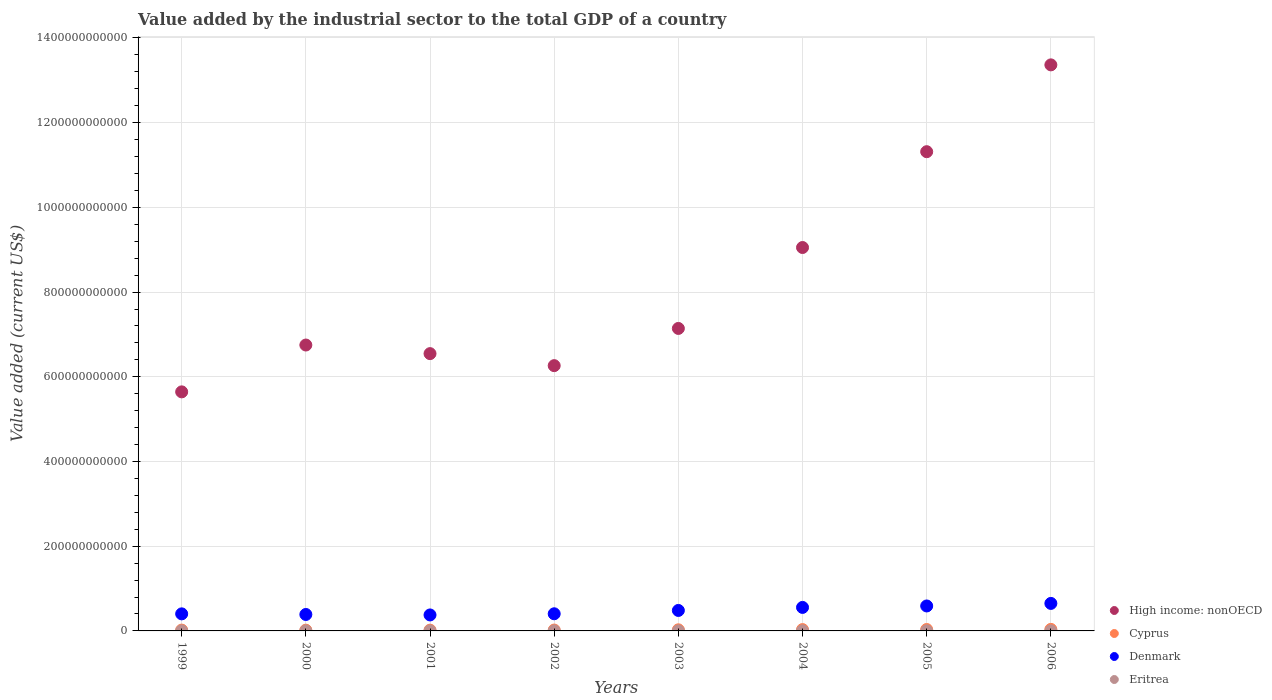How many different coloured dotlines are there?
Provide a short and direct response. 4. What is the value added by the industrial sector to the total GDP in High income: nonOECD in 2004?
Provide a short and direct response. 9.05e+11. Across all years, what is the maximum value added by the industrial sector to the total GDP in Eritrea?
Ensure brevity in your answer.  2.25e+08. Across all years, what is the minimum value added by the industrial sector to the total GDP in High income: nonOECD?
Offer a terse response. 5.64e+11. In which year was the value added by the industrial sector to the total GDP in High income: nonOECD maximum?
Give a very brief answer. 2006. What is the total value added by the industrial sector to the total GDP in Denmark in the graph?
Your answer should be compact. 3.85e+11. What is the difference between the value added by the industrial sector to the total GDP in Cyprus in 2000 and that in 2001?
Ensure brevity in your answer.  -4.46e+07. What is the difference between the value added by the industrial sector to the total GDP in Denmark in 2002 and the value added by the industrial sector to the total GDP in Eritrea in 2000?
Provide a succinct answer. 4.03e+1. What is the average value added by the industrial sector to the total GDP in Denmark per year?
Provide a short and direct response. 4.81e+1. In the year 2000, what is the difference between the value added by the industrial sector to the total GDP in High income: nonOECD and value added by the industrial sector to the total GDP in Eritrea?
Provide a succinct answer. 6.75e+11. What is the ratio of the value added by the industrial sector to the total GDP in Cyprus in 1999 to that in 2001?
Keep it short and to the point. 1.07. What is the difference between the highest and the second highest value added by the industrial sector to the total GDP in Denmark?
Provide a short and direct response. 6.02e+09. What is the difference between the highest and the lowest value added by the industrial sector to the total GDP in Cyprus?
Keep it short and to the point. 1.83e+09. Is the value added by the industrial sector to the total GDP in Cyprus strictly greater than the value added by the industrial sector to the total GDP in Denmark over the years?
Make the answer very short. No. How many dotlines are there?
Provide a succinct answer. 4. How many years are there in the graph?
Your answer should be compact. 8. What is the difference between two consecutive major ticks on the Y-axis?
Your response must be concise. 2.00e+11. Are the values on the major ticks of Y-axis written in scientific E-notation?
Make the answer very short. No. How many legend labels are there?
Provide a succinct answer. 4. What is the title of the graph?
Offer a terse response. Value added by the industrial sector to the total GDP of a country. Does "Suriname" appear as one of the legend labels in the graph?
Your response must be concise. No. What is the label or title of the X-axis?
Give a very brief answer. Years. What is the label or title of the Y-axis?
Give a very brief answer. Value added (current US$). What is the Value added (current US$) in High income: nonOECD in 1999?
Offer a very short reply. 5.64e+11. What is the Value added (current US$) of Cyprus in 1999?
Provide a short and direct response. 1.96e+09. What is the Value added (current US$) in Denmark in 1999?
Provide a succinct answer. 4.03e+1. What is the Value added (current US$) in Eritrea in 1999?
Your response must be concise. 1.44e+08. What is the Value added (current US$) of High income: nonOECD in 2000?
Make the answer very short. 6.75e+11. What is the Value added (current US$) in Cyprus in 2000?
Give a very brief answer. 1.78e+09. What is the Value added (current US$) of Denmark in 2000?
Keep it short and to the point. 3.88e+1. What is the Value added (current US$) of Eritrea in 2000?
Ensure brevity in your answer.  1.35e+08. What is the Value added (current US$) of High income: nonOECD in 2001?
Provide a short and direct response. 6.55e+11. What is the Value added (current US$) of Cyprus in 2001?
Give a very brief answer. 1.83e+09. What is the Value added (current US$) in Denmark in 2001?
Provide a succinct answer. 3.77e+1. What is the Value added (current US$) in Eritrea in 2001?
Your response must be concise. 1.39e+08. What is the Value added (current US$) in High income: nonOECD in 2002?
Provide a succinct answer. 6.26e+11. What is the Value added (current US$) of Cyprus in 2002?
Provide a succinct answer. 2.07e+09. What is the Value added (current US$) in Denmark in 2002?
Your response must be concise. 4.05e+1. What is the Value added (current US$) in Eritrea in 2002?
Your response must be concise. 1.40e+08. What is the Value added (current US$) of High income: nonOECD in 2003?
Provide a short and direct response. 7.14e+11. What is the Value added (current US$) in Cyprus in 2003?
Your answer should be compact. 2.64e+09. What is the Value added (current US$) of Denmark in 2003?
Provide a succinct answer. 4.83e+1. What is the Value added (current US$) of Eritrea in 2003?
Give a very brief answer. 1.71e+08. What is the Value added (current US$) of High income: nonOECD in 2004?
Your answer should be compact. 9.05e+11. What is the Value added (current US$) in Cyprus in 2004?
Make the answer very short. 3.17e+09. What is the Value added (current US$) of Denmark in 2004?
Make the answer very short. 5.55e+1. What is the Value added (current US$) in Eritrea in 2004?
Ensure brevity in your answer.  2.18e+08. What is the Value added (current US$) in High income: nonOECD in 2005?
Offer a terse response. 1.13e+12. What is the Value added (current US$) of Cyprus in 2005?
Provide a short and direct response. 3.34e+09. What is the Value added (current US$) in Denmark in 2005?
Keep it short and to the point. 5.89e+1. What is the Value added (current US$) of Eritrea in 2005?
Provide a short and direct response. 2.25e+08. What is the Value added (current US$) of High income: nonOECD in 2006?
Provide a short and direct response. 1.34e+12. What is the Value added (current US$) of Cyprus in 2006?
Your response must be concise. 3.62e+09. What is the Value added (current US$) of Denmark in 2006?
Offer a very short reply. 6.49e+1. What is the Value added (current US$) of Eritrea in 2006?
Offer a terse response. 2.20e+08. Across all years, what is the maximum Value added (current US$) in High income: nonOECD?
Make the answer very short. 1.34e+12. Across all years, what is the maximum Value added (current US$) in Cyprus?
Give a very brief answer. 3.62e+09. Across all years, what is the maximum Value added (current US$) of Denmark?
Give a very brief answer. 6.49e+1. Across all years, what is the maximum Value added (current US$) of Eritrea?
Make the answer very short. 2.25e+08. Across all years, what is the minimum Value added (current US$) of High income: nonOECD?
Your response must be concise. 5.64e+11. Across all years, what is the minimum Value added (current US$) in Cyprus?
Offer a terse response. 1.78e+09. Across all years, what is the minimum Value added (current US$) in Denmark?
Offer a very short reply. 3.77e+1. Across all years, what is the minimum Value added (current US$) in Eritrea?
Keep it short and to the point. 1.35e+08. What is the total Value added (current US$) in High income: nonOECD in the graph?
Ensure brevity in your answer.  6.61e+12. What is the total Value added (current US$) of Cyprus in the graph?
Keep it short and to the point. 2.04e+1. What is the total Value added (current US$) in Denmark in the graph?
Keep it short and to the point. 3.85e+11. What is the total Value added (current US$) in Eritrea in the graph?
Make the answer very short. 1.39e+09. What is the difference between the Value added (current US$) in High income: nonOECD in 1999 and that in 2000?
Ensure brevity in your answer.  -1.11e+11. What is the difference between the Value added (current US$) of Cyprus in 1999 and that in 2000?
Your response must be concise. 1.76e+08. What is the difference between the Value added (current US$) of Denmark in 1999 and that in 2000?
Make the answer very short. 1.46e+09. What is the difference between the Value added (current US$) of Eritrea in 1999 and that in 2000?
Your answer should be very brief. 8.46e+06. What is the difference between the Value added (current US$) in High income: nonOECD in 1999 and that in 2001?
Make the answer very short. -9.03e+1. What is the difference between the Value added (current US$) in Cyprus in 1999 and that in 2001?
Provide a succinct answer. 1.31e+08. What is the difference between the Value added (current US$) in Denmark in 1999 and that in 2001?
Provide a short and direct response. 2.57e+09. What is the difference between the Value added (current US$) of Eritrea in 1999 and that in 2001?
Ensure brevity in your answer.  4.37e+06. What is the difference between the Value added (current US$) in High income: nonOECD in 1999 and that in 2002?
Make the answer very short. -6.19e+1. What is the difference between the Value added (current US$) in Cyprus in 1999 and that in 2002?
Your answer should be very brief. -1.07e+08. What is the difference between the Value added (current US$) of Denmark in 1999 and that in 2002?
Keep it short and to the point. -1.83e+08. What is the difference between the Value added (current US$) in Eritrea in 1999 and that in 2002?
Ensure brevity in your answer.  3.97e+06. What is the difference between the Value added (current US$) of High income: nonOECD in 1999 and that in 2003?
Make the answer very short. -1.50e+11. What is the difference between the Value added (current US$) in Cyprus in 1999 and that in 2003?
Offer a very short reply. -6.85e+08. What is the difference between the Value added (current US$) of Denmark in 1999 and that in 2003?
Make the answer very short. -8.05e+09. What is the difference between the Value added (current US$) of Eritrea in 1999 and that in 2003?
Your answer should be compact. -2.76e+07. What is the difference between the Value added (current US$) of High income: nonOECD in 1999 and that in 2004?
Your answer should be very brief. -3.41e+11. What is the difference between the Value added (current US$) of Cyprus in 1999 and that in 2004?
Ensure brevity in your answer.  -1.21e+09. What is the difference between the Value added (current US$) in Denmark in 1999 and that in 2004?
Offer a terse response. -1.52e+1. What is the difference between the Value added (current US$) in Eritrea in 1999 and that in 2004?
Make the answer very short. -7.37e+07. What is the difference between the Value added (current US$) of High income: nonOECD in 1999 and that in 2005?
Your answer should be very brief. -5.67e+11. What is the difference between the Value added (current US$) of Cyprus in 1999 and that in 2005?
Provide a short and direct response. -1.38e+09. What is the difference between the Value added (current US$) of Denmark in 1999 and that in 2005?
Offer a very short reply. -1.86e+1. What is the difference between the Value added (current US$) in Eritrea in 1999 and that in 2005?
Provide a succinct answer. -8.10e+07. What is the difference between the Value added (current US$) in High income: nonOECD in 1999 and that in 2006?
Make the answer very short. -7.72e+11. What is the difference between the Value added (current US$) of Cyprus in 1999 and that in 2006?
Offer a terse response. -1.66e+09. What is the difference between the Value added (current US$) of Denmark in 1999 and that in 2006?
Keep it short and to the point. -2.46e+1. What is the difference between the Value added (current US$) in Eritrea in 1999 and that in 2006?
Provide a short and direct response. -7.61e+07. What is the difference between the Value added (current US$) of High income: nonOECD in 2000 and that in 2001?
Offer a very short reply. 2.03e+1. What is the difference between the Value added (current US$) of Cyprus in 2000 and that in 2001?
Ensure brevity in your answer.  -4.46e+07. What is the difference between the Value added (current US$) in Denmark in 2000 and that in 2001?
Give a very brief answer. 1.11e+09. What is the difference between the Value added (current US$) in Eritrea in 2000 and that in 2001?
Make the answer very short. -4.09e+06. What is the difference between the Value added (current US$) in High income: nonOECD in 2000 and that in 2002?
Give a very brief answer. 4.87e+1. What is the difference between the Value added (current US$) of Cyprus in 2000 and that in 2002?
Your answer should be very brief. -2.83e+08. What is the difference between the Value added (current US$) of Denmark in 2000 and that in 2002?
Provide a succinct answer. -1.64e+09. What is the difference between the Value added (current US$) of Eritrea in 2000 and that in 2002?
Offer a very short reply. -4.49e+06. What is the difference between the Value added (current US$) in High income: nonOECD in 2000 and that in 2003?
Your answer should be very brief. -3.92e+1. What is the difference between the Value added (current US$) of Cyprus in 2000 and that in 2003?
Provide a succinct answer. -8.61e+08. What is the difference between the Value added (current US$) in Denmark in 2000 and that in 2003?
Offer a very short reply. -9.51e+09. What is the difference between the Value added (current US$) of Eritrea in 2000 and that in 2003?
Keep it short and to the point. -3.61e+07. What is the difference between the Value added (current US$) in High income: nonOECD in 2000 and that in 2004?
Your answer should be compact. -2.30e+11. What is the difference between the Value added (current US$) in Cyprus in 2000 and that in 2004?
Your answer should be very brief. -1.38e+09. What is the difference between the Value added (current US$) in Denmark in 2000 and that in 2004?
Offer a very short reply. -1.67e+1. What is the difference between the Value added (current US$) of Eritrea in 2000 and that in 2004?
Make the answer very short. -8.22e+07. What is the difference between the Value added (current US$) of High income: nonOECD in 2000 and that in 2005?
Provide a short and direct response. -4.56e+11. What is the difference between the Value added (current US$) of Cyprus in 2000 and that in 2005?
Keep it short and to the point. -1.55e+09. What is the difference between the Value added (current US$) of Denmark in 2000 and that in 2005?
Your answer should be very brief. -2.01e+1. What is the difference between the Value added (current US$) in Eritrea in 2000 and that in 2005?
Your response must be concise. -8.94e+07. What is the difference between the Value added (current US$) in High income: nonOECD in 2000 and that in 2006?
Offer a terse response. -6.61e+11. What is the difference between the Value added (current US$) of Cyprus in 2000 and that in 2006?
Your answer should be compact. -1.83e+09. What is the difference between the Value added (current US$) of Denmark in 2000 and that in 2006?
Your response must be concise. -2.61e+1. What is the difference between the Value added (current US$) in Eritrea in 2000 and that in 2006?
Your response must be concise. -8.45e+07. What is the difference between the Value added (current US$) in High income: nonOECD in 2001 and that in 2002?
Offer a terse response. 2.84e+1. What is the difference between the Value added (current US$) of Cyprus in 2001 and that in 2002?
Keep it short and to the point. -2.38e+08. What is the difference between the Value added (current US$) in Denmark in 2001 and that in 2002?
Offer a terse response. -2.75e+09. What is the difference between the Value added (current US$) of Eritrea in 2001 and that in 2002?
Keep it short and to the point. -3.99e+05. What is the difference between the Value added (current US$) of High income: nonOECD in 2001 and that in 2003?
Ensure brevity in your answer.  -5.95e+1. What is the difference between the Value added (current US$) in Cyprus in 2001 and that in 2003?
Offer a very short reply. -8.16e+08. What is the difference between the Value added (current US$) in Denmark in 2001 and that in 2003?
Make the answer very short. -1.06e+1. What is the difference between the Value added (current US$) in Eritrea in 2001 and that in 2003?
Offer a terse response. -3.20e+07. What is the difference between the Value added (current US$) of High income: nonOECD in 2001 and that in 2004?
Give a very brief answer. -2.51e+11. What is the difference between the Value added (current US$) of Cyprus in 2001 and that in 2004?
Offer a terse response. -1.34e+09. What is the difference between the Value added (current US$) of Denmark in 2001 and that in 2004?
Your answer should be very brief. -1.78e+1. What is the difference between the Value added (current US$) in Eritrea in 2001 and that in 2004?
Give a very brief answer. -7.81e+07. What is the difference between the Value added (current US$) in High income: nonOECD in 2001 and that in 2005?
Offer a very short reply. -4.77e+11. What is the difference between the Value added (current US$) in Cyprus in 2001 and that in 2005?
Provide a short and direct response. -1.51e+09. What is the difference between the Value added (current US$) of Denmark in 2001 and that in 2005?
Provide a short and direct response. -2.12e+1. What is the difference between the Value added (current US$) of Eritrea in 2001 and that in 2005?
Ensure brevity in your answer.  -8.53e+07. What is the difference between the Value added (current US$) in High income: nonOECD in 2001 and that in 2006?
Provide a short and direct response. -6.82e+11. What is the difference between the Value added (current US$) in Cyprus in 2001 and that in 2006?
Offer a very short reply. -1.79e+09. What is the difference between the Value added (current US$) in Denmark in 2001 and that in 2006?
Offer a very short reply. -2.72e+1. What is the difference between the Value added (current US$) in Eritrea in 2001 and that in 2006?
Give a very brief answer. -8.04e+07. What is the difference between the Value added (current US$) in High income: nonOECD in 2002 and that in 2003?
Ensure brevity in your answer.  -8.78e+1. What is the difference between the Value added (current US$) of Cyprus in 2002 and that in 2003?
Offer a terse response. -5.78e+08. What is the difference between the Value added (current US$) in Denmark in 2002 and that in 2003?
Keep it short and to the point. -7.87e+09. What is the difference between the Value added (current US$) in Eritrea in 2002 and that in 2003?
Keep it short and to the point. -3.16e+07. What is the difference between the Value added (current US$) in High income: nonOECD in 2002 and that in 2004?
Provide a short and direct response. -2.79e+11. What is the difference between the Value added (current US$) in Cyprus in 2002 and that in 2004?
Provide a short and direct response. -1.10e+09. What is the difference between the Value added (current US$) in Denmark in 2002 and that in 2004?
Keep it short and to the point. -1.50e+1. What is the difference between the Value added (current US$) of Eritrea in 2002 and that in 2004?
Your answer should be compact. -7.77e+07. What is the difference between the Value added (current US$) in High income: nonOECD in 2002 and that in 2005?
Keep it short and to the point. -5.05e+11. What is the difference between the Value added (current US$) in Cyprus in 2002 and that in 2005?
Keep it short and to the point. -1.27e+09. What is the difference between the Value added (current US$) of Denmark in 2002 and that in 2005?
Your answer should be very brief. -1.84e+1. What is the difference between the Value added (current US$) in Eritrea in 2002 and that in 2005?
Keep it short and to the point. -8.49e+07. What is the difference between the Value added (current US$) of High income: nonOECD in 2002 and that in 2006?
Your response must be concise. -7.10e+11. What is the difference between the Value added (current US$) of Cyprus in 2002 and that in 2006?
Offer a terse response. -1.55e+09. What is the difference between the Value added (current US$) of Denmark in 2002 and that in 2006?
Provide a succinct answer. -2.45e+1. What is the difference between the Value added (current US$) of Eritrea in 2002 and that in 2006?
Offer a terse response. -8.00e+07. What is the difference between the Value added (current US$) of High income: nonOECD in 2003 and that in 2004?
Provide a short and direct response. -1.91e+11. What is the difference between the Value added (current US$) of Cyprus in 2003 and that in 2004?
Your answer should be very brief. -5.21e+08. What is the difference between the Value added (current US$) of Denmark in 2003 and that in 2004?
Keep it short and to the point. -7.16e+09. What is the difference between the Value added (current US$) in Eritrea in 2003 and that in 2004?
Ensure brevity in your answer.  -4.61e+07. What is the difference between the Value added (current US$) of High income: nonOECD in 2003 and that in 2005?
Offer a terse response. -4.17e+11. What is the difference between the Value added (current US$) of Cyprus in 2003 and that in 2005?
Your answer should be compact. -6.91e+08. What is the difference between the Value added (current US$) of Denmark in 2003 and that in 2005?
Your response must be concise. -1.06e+1. What is the difference between the Value added (current US$) in Eritrea in 2003 and that in 2005?
Ensure brevity in your answer.  -5.34e+07. What is the difference between the Value added (current US$) of High income: nonOECD in 2003 and that in 2006?
Offer a very short reply. -6.22e+11. What is the difference between the Value added (current US$) of Cyprus in 2003 and that in 2006?
Make the answer very short. -9.73e+08. What is the difference between the Value added (current US$) of Denmark in 2003 and that in 2006?
Make the answer very short. -1.66e+1. What is the difference between the Value added (current US$) in Eritrea in 2003 and that in 2006?
Give a very brief answer. -4.85e+07. What is the difference between the Value added (current US$) in High income: nonOECD in 2004 and that in 2005?
Ensure brevity in your answer.  -2.26e+11. What is the difference between the Value added (current US$) in Cyprus in 2004 and that in 2005?
Provide a succinct answer. -1.69e+08. What is the difference between the Value added (current US$) of Denmark in 2004 and that in 2005?
Ensure brevity in your answer.  -3.41e+09. What is the difference between the Value added (current US$) of Eritrea in 2004 and that in 2005?
Your answer should be very brief. -7.25e+06. What is the difference between the Value added (current US$) in High income: nonOECD in 2004 and that in 2006?
Keep it short and to the point. -4.31e+11. What is the difference between the Value added (current US$) of Cyprus in 2004 and that in 2006?
Provide a succinct answer. -4.51e+08. What is the difference between the Value added (current US$) of Denmark in 2004 and that in 2006?
Offer a terse response. -9.43e+09. What is the difference between the Value added (current US$) of Eritrea in 2004 and that in 2006?
Your answer should be very brief. -2.35e+06. What is the difference between the Value added (current US$) of High income: nonOECD in 2005 and that in 2006?
Your response must be concise. -2.05e+11. What is the difference between the Value added (current US$) of Cyprus in 2005 and that in 2006?
Your response must be concise. -2.82e+08. What is the difference between the Value added (current US$) in Denmark in 2005 and that in 2006?
Give a very brief answer. -6.02e+09. What is the difference between the Value added (current US$) in Eritrea in 2005 and that in 2006?
Give a very brief answer. 4.90e+06. What is the difference between the Value added (current US$) in High income: nonOECD in 1999 and the Value added (current US$) in Cyprus in 2000?
Provide a short and direct response. 5.63e+11. What is the difference between the Value added (current US$) of High income: nonOECD in 1999 and the Value added (current US$) of Denmark in 2000?
Offer a terse response. 5.26e+11. What is the difference between the Value added (current US$) of High income: nonOECD in 1999 and the Value added (current US$) of Eritrea in 2000?
Provide a succinct answer. 5.64e+11. What is the difference between the Value added (current US$) of Cyprus in 1999 and the Value added (current US$) of Denmark in 2000?
Provide a succinct answer. -3.69e+1. What is the difference between the Value added (current US$) of Cyprus in 1999 and the Value added (current US$) of Eritrea in 2000?
Your answer should be very brief. 1.82e+09. What is the difference between the Value added (current US$) of Denmark in 1999 and the Value added (current US$) of Eritrea in 2000?
Your answer should be very brief. 4.02e+1. What is the difference between the Value added (current US$) in High income: nonOECD in 1999 and the Value added (current US$) in Cyprus in 2001?
Provide a succinct answer. 5.63e+11. What is the difference between the Value added (current US$) of High income: nonOECD in 1999 and the Value added (current US$) of Denmark in 2001?
Provide a short and direct response. 5.27e+11. What is the difference between the Value added (current US$) in High income: nonOECD in 1999 and the Value added (current US$) in Eritrea in 2001?
Offer a very short reply. 5.64e+11. What is the difference between the Value added (current US$) in Cyprus in 1999 and the Value added (current US$) in Denmark in 2001?
Your answer should be very brief. -3.58e+1. What is the difference between the Value added (current US$) in Cyprus in 1999 and the Value added (current US$) in Eritrea in 2001?
Your response must be concise. 1.82e+09. What is the difference between the Value added (current US$) of Denmark in 1999 and the Value added (current US$) of Eritrea in 2001?
Provide a succinct answer. 4.01e+1. What is the difference between the Value added (current US$) in High income: nonOECD in 1999 and the Value added (current US$) in Cyprus in 2002?
Keep it short and to the point. 5.62e+11. What is the difference between the Value added (current US$) of High income: nonOECD in 1999 and the Value added (current US$) of Denmark in 2002?
Offer a very short reply. 5.24e+11. What is the difference between the Value added (current US$) in High income: nonOECD in 1999 and the Value added (current US$) in Eritrea in 2002?
Offer a terse response. 5.64e+11. What is the difference between the Value added (current US$) in Cyprus in 1999 and the Value added (current US$) in Denmark in 2002?
Offer a very short reply. -3.85e+1. What is the difference between the Value added (current US$) in Cyprus in 1999 and the Value added (current US$) in Eritrea in 2002?
Make the answer very short. 1.82e+09. What is the difference between the Value added (current US$) of Denmark in 1999 and the Value added (current US$) of Eritrea in 2002?
Offer a very short reply. 4.01e+1. What is the difference between the Value added (current US$) of High income: nonOECD in 1999 and the Value added (current US$) of Cyprus in 2003?
Make the answer very short. 5.62e+11. What is the difference between the Value added (current US$) in High income: nonOECD in 1999 and the Value added (current US$) in Denmark in 2003?
Ensure brevity in your answer.  5.16e+11. What is the difference between the Value added (current US$) in High income: nonOECD in 1999 and the Value added (current US$) in Eritrea in 2003?
Provide a short and direct response. 5.64e+11. What is the difference between the Value added (current US$) in Cyprus in 1999 and the Value added (current US$) in Denmark in 2003?
Give a very brief answer. -4.64e+1. What is the difference between the Value added (current US$) in Cyprus in 1999 and the Value added (current US$) in Eritrea in 2003?
Your answer should be compact. 1.79e+09. What is the difference between the Value added (current US$) in Denmark in 1999 and the Value added (current US$) in Eritrea in 2003?
Your response must be concise. 4.01e+1. What is the difference between the Value added (current US$) of High income: nonOECD in 1999 and the Value added (current US$) of Cyprus in 2004?
Your response must be concise. 5.61e+11. What is the difference between the Value added (current US$) in High income: nonOECD in 1999 and the Value added (current US$) in Denmark in 2004?
Your response must be concise. 5.09e+11. What is the difference between the Value added (current US$) of High income: nonOECD in 1999 and the Value added (current US$) of Eritrea in 2004?
Keep it short and to the point. 5.64e+11. What is the difference between the Value added (current US$) of Cyprus in 1999 and the Value added (current US$) of Denmark in 2004?
Offer a terse response. -5.35e+1. What is the difference between the Value added (current US$) of Cyprus in 1999 and the Value added (current US$) of Eritrea in 2004?
Make the answer very short. 1.74e+09. What is the difference between the Value added (current US$) of Denmark in 1999 and the Value added (current US$) of Eritrea in 2004?
Provide a short and direct response. 4.01e+1. What is the difference between the Value added (current US$) in High income: nonOECD in 1999 and the Value added (current US$) in Cyprus in 2005?
Ensure brevity in your answer.  5.61e+11. What is the difference between the Value added (current US$) of High income: nonOECD in 1999 and the Value added (current US$) of Denmark in 2005?
Provide a short and direct response. 5.05e+11. What is the difference between the Value added (current US$) in High income: nonOECD in 1999 and the Value added (current US$) in Eritrea in 2005?
Keep it short and to the point. 5.64e+11. What is the difference between the Value added (current US$) of Cyprus in 1999 and the Value added (current US$) of Denmark in 2005?
Your answer should be compact. -5.70e+1. What is the difference between the Value added (current US$) of Cyprus in 1999 and the Value added (current US$) of Eritrea in 2005?
Provide a short and direct response. 1.74e+09. What is the difference between the Value added (current US$) of Denmark in 1999 and the Value added (current US$) of Eritrea in 2005?
Offer a terse response. 4.01e+1. What is the difference between the Value added (current US$) in High income: nonOECD in 1999 and the Value added (current US$) in Cyprus in 2006?
Provide a succinct answer. 5.61e+11. What is the difference between the Value added (current US$) of High income: nonOECD in 1999 and the Value added (current US$) of Denmark in 2006?
Your response must be concise. 4.99e+11. What is the difference between the Value added (current US$) of High income: nonOECD in 1999 and the Value added (current US$) of Eritrea in 2006?
Make the answer very short. 5.64e+11. What is the difference between the Value added (current US$) of Cyprus in 1999 and the Value added (current US$) of Denmark in 2006?
Your response must be concise. -6.30e+1. What is the difference between the Value added (current US$) in Cyprus in 1999 and the Value added (current US$) in Eritrea in 2006?
Offer a very short reply. 1.74e+09. What is the difference between the Value added (current US$) of Denmark in 1999 and the Value added (current US$) of Eritrea in 2006?
Keep it short and to the point. 4.01e+1. What is the difference between the Value added (current US$) of High income: nonOECD in 2000 and the Value added (current US$) of Cyprus in 2001?
Keep it short and to the point. 6.73e+11. What is the difference between the Value added (current US$) of High income: nonOECD in 2000 and the Value added (current US$) of Denmark in 2001?
Your answer should be very brief. 6.37e+11. What is the difference between the Value added (current US$) of High income: nonOECD in 2000 and the Value added (current US$) of Eritrea in 2001?
Keep it short and to the point. 6.75e+11. What is the difference between the Value added (current US$) in Cyprus in 2000 and the Value added (current US$) in Denmark in 2001?
Offer a very short reply. -3.59e+1. What is the difference between the Value added (current US$) in Cyprus in 2000 and the Value added (current US$) in Eritrea in 2001?
Offer a very short reply. 1.64e+09. What is the difference between the Value added (current US$) of Denmark in 2000 and the Value added (current US$) of Eritrea in 2001?
Offer a terse response. 3.87e+1. What is the difference between the Value added (current US$) in High income: nonOECD in 2000 and the Value added (current US$) in Cyprus in 2002?
Your answer should be compact. 6.73e+11. What is the difference between the Value added (current US$) of High income: nonOECD in 2000 and the Value added (current US$) of Denmark in 2002?
Your answer should be compact. 6.35e+11. What is the difference between the Value added (current US$) in High income: nonOECD in 2000 and the Value added (current US$) in Eritrea in 2002?
Provide a succinct answer. 6.75e+11. What is the difference between the Value added (current US$) in Cyprus in 2000 and the Value added (current US$) in Denmark in 2002?
Your answer should be very brief. -3.87e+1. What is the difference between the Value added (current US$) in Cyprus in 2000 and the Value added (current US$) in Eritrea in 2002?
Give a very brief answer. 1.64e+09. What is the difference between the Value added (current US$) in Denmark in 2000 and the Value added (current US$) in Eritrea in 2002?
Make the answer very short. 3.87e+1. What is the difference between the Value added (current US$) in High income: nonOECD in 2000 and the Value added (current US$) in Cyprus in 2003?
Ensure brevity in your answer.  6.72e+11. What is the difference between the Value added (current US$) in High income: nonOECD in 2000 and the Value added (current US$) in Denmark in 2003?
Offer a terse response. 6.27e+11. What is the difference between the Value added (current US$) of High income: nonOECD in 2000 and the Value added (current US$) of Eritrea in 2003?
Your answer should be compact. 6.75e+11. What is the difference between the Value added (current US$) in Cyprus in 2000 and the Value added (current US$) in Denmark in 2003?
Keep it short and to the point. -4.66e+1. What is the difference between the Value added (current US$) in Cyprus in 2000 and the Value added (current US$) in Eritrea in 2003?
Offer a very short reply. 1.61e+09. What is the difference between the Value added (current US$) in Denmark in 2000 and the Value added (current US$) in Eritrea in 2003?
Provide a succinct answer. 3.87e+1. What is the difference between the Value added (current US$) in High income: nonOECD in 2000 and the Value added (current US$) in Cyprus in 2004?
Provide a succinct answer. 6.72e+11. What is the difference between the Value added (current US$) of High income: nonOECD in 2000 and the Value added (current US$) of Denmark in 2004?
Offer a very short reply. 6.19e+11. What is the difference between the Value added (current US$) in High income: nonOECD in 2000 and the Value added (current US$) in Eritrea in 2004?
Give a very brief answer. 6.75e+11. What is the difference between the Value added (current US$) in Cyprus in 2000 and the Value added (current US$) in Denmark in 2004?
Offer a very short reply. -5.37e+1. What is the difference between the Value added (current US$) in Cyprus in 2000 and the Value added (current US$) in Eritrea in 2004?
Offer a very short reply. 1.57e+09. What is the difference between the Value added (current US$) of Denmark in 2000 and the Value added (current US$) of Eritrea in 2004?
Provide a succinct answer. 3.86e+1. What is the difference between the Value added (current US$) of High income: nonOECD in 2000 and the Value added (current US$) of Cyprus in 2005?
Ensure brevity in your answer.  6.72e+11. What is the difference between the Value added (current US$) in High income: nonOECD in 2000 and the Value added (current US$) in Denmark in 2005?
Your response must be concise. 6.16e+11. What is the difference between the Value added (current US$) of High income: nonOECD in 2000 and the Value added (current US$) of Eritrea in 2005?
Your answer should be very brief. 6.75e+11. What is the difference between the Value added (current US$) of Cyprus in 2000 and the Value added (current US$) of Denmark in 2005?
Give a very brief answer. -5.71e+1. What is the difference between the Value added (current US$) of Cyprus in 2000 and the Value added (current US$) of Eritrea in 2005?
Your answer should be very brief. 1.56e+09. What is the difference between the Value added (current US$) of Denmark in 2000 and the Value added (current US$) of Eritrea in 2005?
Ensure brevity in your answer.  3.86e+1. What is the difference between the Value added (current US$) in High income: nonOECD in 2000 and the Value added (current US$) in Cyprus in 2006?
Your response must be concise. 6.71e+11. What is the difference between the Value added (current US$) in High income: nonOECD in 2000 and the Value added (current US$) in Denmark in 2006?
Keep it short and to the point. 6.10e+11. What is the difference between the Value added (current US$) of High income: nonOECD in 2000 and the Value added (current US$) of Eritrea in 2006?
Keep it short and to the point. 6.75e+11. What is the difference between the Value added (current US$) in Cyprus in 2000 and the Value added (current US$) in Denmark in 2006?
Offer a very short reply. -6.31e+1. What is the difference between the Value added (current US$) of Cyprus in 2000 and the Value added (current US$) of Eritrea in 2006?
Keep it short and to the point. 1.56e+09. What is the difference between the Value added (current US$) of Denmark in 2000 and the Value added (current US$) of Eritrea in 2006?
Your response must be concise. 3.86e+1. What is the difference between the Value added (current US$) in High income: nonOECD in 2001 and the Value added (current US$) in Cyprus in 2002?
Provide a succinct answer. 6.53e+11. What is the difference between the Value added (current US$) in High income: nonOECD in 2001 and the Value added (current US$) in Denmark in 2002?
Provide a short and direct response. 6.14e+11. What is the difference between the Value added (current US$) of High income: nonOECD in 2001 and the Value added (current US$) of Eritrea in 2002?
Provide a short and direct response. 6.55e+11. What is the difference between the Value added (current US$) in Cyprus in 2001 and the Value added (current US$) in Denmark in 2002?
Give a very brief answer. -3.86e+1. What is the difference between the Value added (current US$) in Cyprus in 2001 and the Value added (current US$) in Eritrea in 2002?
Your response must be concise. 1.69e+09. What is the difference between the Value added (current US$) in Denmark in 2001 and the Value added (current US$) in Eritrea in 2002?
Keep it short and to the point. 3.76e+1. What is the difference between the Value added (current US$) of High income: nonOECD in 2001 and the Value added (current US$) of Cyprus in 2003?
Keep it short and to the point. 6.52e+11. What is the difference between the Value added (current US$) in High income: nonOECD in 2001 and the Value added (current US$) in Denmark in 2003?
Offer a terse response. 6.06e+11. What is the difference between the Value added (current US$) in High income: nonOECD in 2001 and the Value added (current US$) in Eritrea in 2003?
Provide a succinct answer. 6.54e+11. What is the difference between the Value added (current US$) of Cyprus in 2001 and the Value added (current US$) of Denmark in 2003?
Offer a terse response. -4.65e+1. What is the difference between the Value added (current US$) in Cyprus in 2001 and the Value added (current US$) in Eritrea in 2003?
Give a very brief answer. 1.66e+09. What is the difference between the Value added (current US$) of Denmark in 2001 and the Value added (current US$) of Eritrea in 2003?
Provide a short and direct response. 3.76e+1. What is the difference between the Value added (current US$) in High income: nonOECD in 2001 and the Value added (current US$) in Cyprus in 2004?
Your answer should be compact. 6.52e+11. What is the difference between the Value added (current US$) of High income: nonOECD in 2001 and the Value added (current US$) of Denmark in 2004?
Offer a terse response. 5.99e+11. What is the difference between the Value added (current US$) in High income: nonOECD in 2001 and the Value added (current US$) in Eritrea in 2004?
Offer a terse response. 6.54e+11. What is the difference between the Value added (current US$) of Cyprus in 2001 and the Value added (current US$) of Denmark in 2004?
Make the answer very short. -5.37e+1. What is the difference between the Value added (current US$) in Cyprus in 2001 and the Value added (current US$) in Eritrea in 2004?
Keep it short and to the point. 1.61e+09. What is the difference between the Value added (current US$) of Denmark in 2001 and the Value added (current US$) of Eritrea in 2004?
Keep it short and to the point. 3.75e+1. What is the difference between the Value added (current US$) of High income: nonOECD in 2001 and the Value added (current US$) of Cyprus in 2005?
Offer a very short reply. 6.51e+11. What is the difference between the Value added (current US$) of High income: nonOECD in 2001 and the Value added (current US$) of Denmark in 2005?
Provide a succinct answer. 5.96e+11. What is the difference between the Value added (current US$) of High income: nonOECD in 2001 and the Value added (current US$) of Eritrea in 2005?
Make the answer very short. 6.54e+11. What is the difference between the Value added (current US$) of Cyprus in 2001 and the Value added (current US$) of Denmark in 2005?
Ensure brevity in your answer.  -5.71e+1. What is the difference between the Value added (current US$) in Cyprus in 2001 and the Value added (current US$) in Eritrea in 2005?
Offer a very short reply. 1.60e+09. What is the difference between the Value added (current US$) of Denmark in 2001 and the Value added (current US$) of Eritrea in 2005?
Your answer should be very brief. 3.75e+1. What is the difference between the Value added (current US$) of High income: nonOECD in 2001 and the Value added (current US$) of Cyprus in 2006?
Ensure brevity in your answer.  6.51e+11. What is the difference between the Value added (current US$) of High income: nonOECD in 2001 and the Value added (current US$) of Denmark in 2006?
Keep it short and to the point. 5.90e+11. What is the difference between the Value added (current US$) of High income: nonOECD in 2001 and the Value added (current US$) of Eritrea in 2006?
Make the answer very short. 6.54e+11. What is the difference between the Value added (current US$) in Cyprus in 2001 and the Value added (current US$) in Denmark in 2006?
Provide a short and direct response. -6.31e+1. What is the difference between the Value added (current US$) of Cyprus in 2001 and the Value added (current US$) of Eritrea in 2006?
Offer a terse response. 1.61e+09. What is the difference between the Value added (current US$) of Denmark in 2001 and the Value added (current US$) of Eritrea in 2006?
Your answer should be very brief. 3.75e+1. What is the difference between the Value added (current US$) in High income: nonOECD in 2002 and the Value added (current US$) in Cyprus in 2003?
Offer a very short reply. 6.24e+11. What is the difference between the Value added (current US$) of High income: nonOECD in 2002 and the Value added (current US$) of Denmark in 2003?
Provide a succinct answer. 5.78e+11. What is the difference between the Value added (current US$) in High income: nonOECD in 2002 and the Value added (current US$) in Eritrea in 2003?
Offer a very short reply. 6.26e+11. What is the difference between the Value added (current US$) of Cyprus in 2002 and the Value added (current US$) of Denmark in 2003?
Keep it short and to the point. -4.63e+1. What is the difference between the Value added (current US$) in Cyprus in 2002 and the Value added (current US$) in Eritrea in 2003?
Make the answer very short. 1.90e+09. What is the difference between the Value added (current US$) in Denmark in 2002 and the Value added (current US$) in Eritrea in 2003?
Your answer should be compact. 4.03e+1. What is the difference between the Value added (current US$) in High income: nonOECD in 2002 and the Value added (current US$) in Cyprus in 2004?
Provide a short and direct response. 6.23e+11. What is the difference between the Value added (current US$) of High income: nonOECD in 2002 and the Value added (current US$) of Denmark in 2004?
Give a very brief answer. 5.71e+11. What is the difference between the Value added (current US$) of High income: nonOECD in 2002 and the Value added (current US$) of Eritrea in 2004?
Your response must be concise. 6.26e+11. What is the difference between the Value added (current US$) in Cyprus in 2002 and the Value added (current US$) in Denmark in 2004?
Your response must be concise. -5.34e+1. What is the difference between the Value added (current US$) of Cyprus in 2002 and the Value added (current US$) of Eritrea in 2004?
Your response must be concise. 1.85e+09. What is the difference between the Value added (current US$) in Denmark in 2002 and the Value added (current US$) in Eritrea in 2004?
Your response must be concise. 4.03e+1. What is the difference between the Value added (current US$) in High income: nonOECD in 2002 and the Value added (current US$) in Cyprus in 2005?
Ensure brevity in your answer.  6.23e+11. What is the difference between the Value added (current US$) of High income: nonOECD in 2002 and the Value added (current US$) of Denmark in 2005?
Offer a very short reply. 5.67e+11. What is the difference between the Value added (current US$) of High income: nonOECD in 2002 and the Value added (current US$) of Eritrea in 2005?
Provide a succinct answer. 6.26e+11. What is the difference between the Value added (current US$) of Cyprus in 2002 and the Value added (current US$) of Denmark in 2005?
Provide a succinct answer. -5.68e+1. What is the difference between the Value added (current US$) of Cyprus in 2002 and the Value added (current US$) of Eritrea in 2005?
Keep it short and to the point. 1.84e+09. What is the difference between the Value added (current US$) of Denmark in 2002 and the Value added (current US$) of Eritrea in 2005?
Your response must be concise. 4.02e+1. What is the difference between the Value added (current US$) of High income: nonOECD in 2002 and the Value added (current US$) of Cyprus in 2006?
Your answer should be compact. 6.23e+11. What is the difference between the Value added (current US$) of High income: nonOECD in 2002 and the Value added (current US$) of Denmark in 2006?
Offer a very short reply. 5.61e+11. What is the difference between the Value added (current US$) in High income: nonOECD in 2002 and the Value added (current US$) in Eritrea in 2006?
Offer a terse response. 6.26e+11. What is the difference between the Value added (current US$) in Cyprus in 2002 and the Value added (current US$) in Denmark in 2006?
Your answer should be compact. -6.29e+1. What is the difference between the Value added (current US$) of Cyprus in 2002 and the Value added (current US$) of Eritrea in 2006?
Ensure brevity in your answer.  1.85e+09. What is the difference between the Value added (current US$) in Denmark in 2002 and the Value added (current US$) in Eritrea in 2006?
Keep it short and to the point. 4.03e+1. What is the difference between the Value added (current US$) in High income: nonOECD in 2003 and the Value added (current US$) in Cyprus in 2004?
Your response must be concise. 7.11e+11. What is the difference between the Value added (current US$) of High income: nonOECD in 2003 and the Value added (current US$) of Denmark in 2004?
Your answer should be compact. 6.59e+11. What is the difference between the Value added (current US$) in High income: nonOECD in 2003 and the Value added (current US$) in Eritrea in 2004?
Your answer should be compact. 7.14e+11. What is the difference between the Value added (current US$) in Cyprus in 2003 and the Value added (current US$) in Denmark in 2004?
Your answer should be compact. -5.29e+1. What is the difference between the Value added (current US$) of Cyprus in 2003 and the Value added (current US$) of Eritrea in 2004?
Your answer should be compact. 2.43e+09. What is the difference between the Value added (current US$) of Denmark in 2003 and the Value added (current US$) of Eritrea in 2004?
Keep it short and to the point. 4.81e+1. What is the difference between the Value added (current US$) of High income: nonOECD in 2003 and the Value added (current US$) of Cyprus in 2005?
Offer a terse response. 7.11e+11. What is the difference between the Value added (current US$) in High income: nonOECD in 2003 and the Value added (current US$) in Denmark in 2005?
Your answer should be very brief. 6.55e+11. What is the difference between the Value added (current US$) in High income: nonOECD in 2003 and the Value added (current US$) in Eritrea in 2005?
Keep it short and to the point. 7.14e+11. What is the difference between the Value added (current US$) in Cyprus in 2003 and the Value added (current US$) in Denmark in 2005?
Offer a very short reply. -5.63e+1. What is the difference between the Value added (current US$) in Cyprus in 2003 and the Value added (current US$) in Eritrea in 2005?
Give a very brief answer. 2.42e+09. What is the difference between the Value added (current US$) of Denmark in 2003 and the Value added (current US$) of Eritrea in 2005?
Offer a very short reply. 4.81e+1. What is the difference between the Value added (current US$) of High income: nonOECD in 2003 and the Value added (current US$) of Cyprus in 2006?
Keep it short and to the point. 7.11e+11. What is the difference between the Value added (current US$) in High income: nonOECD in 2003 and the Value added (current US$) in Denmark in 2006?
Make the answer very short. 6.49e+11. What is the difference between the Value added (current US$) in High income: nonOECD in 2003 and the Value added (current US$) in Eritrea in 2006?
Ensure brevity in your answer.  7.14e+11. What is the difference between the Value added (current US$) in Cyprus in 2003 and the Value added (current US$) in Denmark in 2006?
Your answer should be very brief. -6.23e+1. What is the difference between the Value added (current US$) in Cyprus in 2003 and the Value added (current US$) in Eritrea in 2006?
Your answer should be compact. 2.42e+09. What is the difference between the Value added (current US$) of Denmark in 2003 and the Value added (current US$) of Eritrea in 2006?
Make the answer very short. 4.81e+1. What is the difference between the Value added (current US$) in High income: nonOECD in 2004 and the Value added (current US$) in Cyprus in 2005?
Your answer should be very brief. 9.02e+11. What is the difference between the Value added (current US$) in High income: nonOECD in 2004 and the Value added (current US$) in Denmark in 2005?
Your answer should be very brief. 8.46e+11. What is the difference between the Value added (current US$) of High income: nonOECD in 2004 and the Value added (current US$) of Eritrea in 2005?
Give a very brief answer. 9.05e+11. What is the difference between the Value added (current US$) of Cyprus in 2004 and the Value added (current US$) of Denmark in 2005?
Offer a terse response. -5.57e+1. What is the difference between the Value added (current US$) of Cyprus in 2004 and the Value added (current US$) of Eritrea in 2005?
Offer a very short reply. 2.94e+09. What is the difference between the Value added (current US$) of Denmark in 2004 and the Value added (current US$) of Eritrea in 2005?
Your answer should be compact. 5.53e+1. What is the difference between the Value added (current US$) in High income: nonOECD in 2004 and the Value added (current US$) in Cyprus in 2006?
Keep it short and to the point. 9.02e+11. What is the difference between the Value added (current US$) in High income: nonOECD in 2004 and the Value added (current US$) in Denmark in 2006?
Make the answer very short. 8.40e+11. What is the difference between the Value added (current US$) in High income: nonOECD in 2004 and the Value added (current US$) in Eritrea in 2006?
Provide a short and direct response. 9.05e+11. What is the difference between the Value added (current US$) in Cyprus in 2004 and the Value added (current US$) in Denmark in 2006?
Your response must be concise. -6.18e+1. What is the difference between the Value added (current US$) in Cyprus in 2004 and the Value added (current US$) in Eritrea in 2006?
Your answer should be compact. 2.95e+09. What is the difference between the Value added (current US$) of Denmark in 2004 and the Value added (current US$) of Eritrea in 2006?
Offer a very short reply. 5.53e+1. What is the difference between the Value added (current US$) of High income: nonOECD in 2005 and the Value added (current US$) of Cyprus in 2006?
Make the answer very short. 1.13e+12. What is the difference between the Value added (current US$) of High income: nonOECD in 2005 and the Value added (current US$) of Denmark in 2006?
Offer a very short reply. 1.07e+12. What is the difference between the Value added (current US$) in High income: nonOECD in 2005 and the Value added (current US$) in Eritrea in 2006?
Your response must be concise. 1.13e+12. What is the difference between the Value added (current US$) in Cyprus in 2005 and the Value added (current US$) in Denmark in 2006?
Your answer should be very brief. -6.16e+1. What is the difference between the Value added (current US$) of Cyprus in 2005 and the Value added (current US$) of Eritrea in 2006?
Provide a short and direct response. 3.12e+09. What is the difference between the Value added (current US$) in Denmark in 2005 and the Value added (current US$) in Eritrea in 2006?
Keep it short and to the point. 5.87e+1. What is the average Value added (current US$) of High income: nonOECD per year?
Keep it short and to the point. 8.26e+11. What is the average Value added (current US$) in Cyprus per year?
Your response must be concise. 2.55e+09. What is the average Value added (current US$) in Denmark per year?
Offer a terse response. 4.81e+1. What is the average Value added (current US$) in Eritrea per year?
Make the answer very short. 1.74e+08. In the year 1999, what is the difference between the Value added (current US$) of High income: nonOECD and Value added (current US$) of Cyprus?
Provide a succinct answer. 5.62e+11. In the year 1999, what is the difference between the Value added (current US$) in High income: nonOECD and Value added (current US$) in Denmark?
Provide a short and direct response. 5.24e+11. In the year 1999, what is the difference between the Value added (current US$) in High income: nonOECD and Value added (current US$) in Eritrea?
Make the answer very short. 5.64e+11. In the year 1999, what is the difference between the Value added (current US$) in Cyprus and Value added (current US$) in Denmark?
Keep it short and to the point. -3.83e+1. In the year 1999, what is the difference between the Value added (current US$) of Cyprus and Value added (current US$) of Eritrea?
Make the answer very short. 1.82e+09. In the year 1999, what is the difference between the Value added (current US$) in Denmark and Value added (current US$) in Eritrea?
Offer a very short reply. 4.01e+1. In the year 2000, what is the difference between the Value added (current US$) of High income: nonOECD and Value added (current US$) of Cyprus?
Keep it short and to the point. 6.73e+11. In the year 2000, what is the difference between the Value added (current US$) in High income: nonOECD and Value added (current US$) in Denmark?
Provide a short and direct response. 6.36e+11. In the year 2000, what is the difference between the Value added (current US$) in High income: nonOECD and Value added (current US$) in Eritrea?
Give a very brief answer. 6.75e+11. In the year 2000, what is the difference between the Value added (current US$) in Cyprus and Value added (current US$) in Denmark?
Offer a terse response. -3.70e+1. In the year 2000, what is the difference between the Value added (current US$) in Cyprus and Value added (current US$) in Eritrea?
Your response must be concise. 1.65e+09. In the year 2000, what is the difference between the Value added (current US$) in Denmark and Value added (current US$) in Eritrea?
Offer a terse response. 3.87e+1. In the year 2001, what is the difference between the Value added (current US$) of High income: nonOECD and Value added (current US$) of Cyprus?
Make the answer very short. 6.53e+11. In the year 2001, what is the difference between the Value added (current US$) of High income: nonOECD and Value added (current US$) of Denmark?
Offer a very short reply. 6.17e+11. In the year 2001, what is the difference between the Value added (current US$) of High income: nonOECD and Value added (current US$) of Eritrea?
Provide a short and direct response. 6.55e+11. In the year 2001, what is the difference between the Value added (current US$) of Cyprus and Value added (current US$) of Denmark?
Provide a succinct answer. -3.59e+1. In the year 2001, what is the difference between the Value added (current US$) in Cyprus and Value added (current US$) in Eritrea?
Make the answer very short. 1.69e+09. In the year 2001, what is the difference between the Value added (current US$) in Denmark and Value added (current US$) in Eritrea?
Give a very brief answer. 3.76e+1. In the year 2002, what is the difference between the Value added (current US$) in High income: nonOECD and Value added (current US$) in Cyprus?
Give a very brief answer. 6.24e+11. In the year 2002, what is the difference between the Value added (current US$) in High income: nonOECD and Value added (current US$) in Denmark?
Your answer should be compact. 5.86e+11. In the year 2002, what is the difference between the Value added (current US$) in High income: nonOECD and Value added (current US$) in Eritrea?
Give a very brief answer. 6.26e+11. In the year 2002, what is the difference between the Value added (current US$) of Cyprus and Value added (current US$) of Denmark?
Offer a very short reply. -3.84e+1. In the year 2002, what is the difference between the Value added (current US$) of Cyprus and Value added (current US$) of Eritrea?
Your response must be concise. 1.93e+09. In the year 2002, what is the difference between the Value added (current US$) in Denmark and Value added (current US$) in Eritrea?
Provide a short and direct response. 4.03e+1. In the year 2003, what is the difference between the Value added (current US$) in High income: nonOECD and Value added (current US$) in Cyprus?
Provide a succinct answer. 7.11e+11. In the year 2003, what is the difference between the Value added (current US$) in High income: nonOECD and Value added (current US$) in Denmark?
Offer a very short reply. 6.66e+11. In the year 2003, what is the difference between the Value added (current US$) in High income: nonOECD and Value added (current US$) in Eritrea?
Provide a succinct answer. 7.14e+11. In the year 2003, what is the difference between the Value added (current US$) in Cyprus and Value added (current US$) in Denmark?
Provide a succinct answer. -4.57e+1. In the year 2003, what is the difference between the Value added (current US$) of Cyprus and Value added (current US$) of Eritrea?
Your answer should be very brief. 2.47e+09. In the year 2003, what is the difference between the Value added (current US$) of Denmark and Value added (current US$) of Eritrea?
Offer a terse response. 4.82e+1. In the year 2004, what is the difference between the Value added (current US$) of High income: nonOECD and Value added (current US$) of Cyprus?
Your answer should be very brief. 9.02e+11. In the year 2004, what is the difference between the Value added (current US$) in High income: nonOECD and Value added (current US$) in Denmark?
Keep it short and to the point. 8.50e+11. In the year 2004, what is the difference between the Value added (current US$) of High income: nonOECD and Value added (current US$) of Eritrea?
Keep it short and to the point. 9.05e+11. In the year 2004, what is the difference between the Value added (current US$) in Cyprus and Value added (current US$) in Denmark?
Ensure brevity in your answer.  -5.23e+1. In the year 2004, what is the difference between the Value added (current US$) in Cyprus and Value added (current US$) in Eritrea?
Keep it short and to the point. 2.95e+09. In the year 2004, what is the difference between the Value added (current US$) in Denmark and Value added (current US$) in Eritrea?
Provide a succinct answer. 5.53e+1. In the year 2005, what is the difference between the Value added (current US$) in High income: nonOECD and Value added (current US$) in Cyprus?
Offer a terse response. 1.13e+12. In the year 2005, what is the difference between the Value added (current US$) of High income: nonOECD and Value added (current US$) of Denmark?
Keep it short and to the point. 1.07e+12. In the year 2005, what is the difference between the Value added (current US$) in High income: nonOECD and Value added (current US$) in Eritrea?
Your response must be concise. 1.13e+12. In the year 2005, what is the difference between the Value added (current US$) in Cyprus and Value added (current US$) in Denmark?
Make the answer very short. -5.56e+1. In the year 2005, what is the difference between the Value added (current US$) in Cyprus and Value added (current US$) in Eritrea?
Offer a very short reply. 3.11e+09. In the year 2005, what is the difference between the Value added (current US$) in Denmark and Value added (current US$) in Eritrea?
Your response must be concise. 5.87e+1. In the year 2006, what is the difference between the Value added (current US$) in High income: nonOECD and Value added (current US$) in Cyprus?
Ensure brevity in your answer.  1.33e+12. In the year 2006, what is the difference between the Value added (current US$) in High income: nonOECD and Value added (current US$) in Denmark?
Offer a terse response. 1.27e+12. In the year 2006, what is the difference between the Value added (current US$) of High income: nonOECD and Value added (current US$) of Eritrea?
Make the answer very short. 1.34e+12. In the year 2006, what is the difference between the Value added (current US$) of Cyprus and Value added (current US$) of Denmark?
Your response must be concise. -6.13e+1. In the year 2006, what is the difference between the Value added (current US$) in Cyprus and Value added (current US$) in Eritrea?
Your response must be concise. 3.40e+09. In the year 2006, what is the difference between the Value added (current US$) of Denmark and Value added (current US$) of Eritrea?
Offer a terse response. 6.47e+1. What is the ratio of the Value added (current US$) in High income: nonOECD in 1999 to that in 2000?
Give a very brief answer. 0.84. What is the ratio of the Value added (current US$) of Cyprus in 1999 to that in 2000?
Give a very brief answer. 1.1. What is the ratio of the Value added (current US$) in Denmark in 1999 to that in 2000?
Offer a very short reply. 1.04. What is the ratio of the Value added (current US$) of High income: nonOECD in 1999 to that in 2001?
Your answer should be very brief. 0.86. What is the ratio of the Value added (current US$) in Cyprus in 1999 to that in 2001?
Make the answer very short. 1.07. What is the ratio of the Value added (current US$) in Denmark in 1999 to that in 2001?
Ensure brevity in your answer.  1.07. What is the ratio of the Value added (current US$) of Eritrea in 1999 to that in 2001?
Your answer should be very brief. 1.03. What is the ratio of the Value added (current US$) in High income: nonOECD in 1999 to that in 2002?
Offer a very short reply. 0.9. What is the ratio of the Value added (current US$) of Cyprus in 1999 to that in 2002?
Offer a terse response. 0.95. What is the ratio of the Value added (current US$) in Eritrea in 1999 to that in 2002?
Your answer should be very brief. 1.03. What is the ratio of the Value added (current US$) in High income: nonOECD in 1999 to that in 2003?
Your answer should be very brief. 0.79. What is the ratio of the Value added (current US$) in Cyprus in 1999 to that in 2003?
Make the answer very short. 0.74. What is the ratio of the Value added (current US$) in Denmark in 1999 to that in 2003?
Offer a terse response. 0.83. What is the ratio of the Value added (current US$) of Eritrea in 1999 to that in 2003?
Your response must be concise. 0.84. What is the ratio of the Value added (current US$) of High income: nonOECD in 1999 to that in 2004?
Offer a terse response. 0.62. What is the ratio of the Value added (current US$) in Cyprus in 1999 to that in 2004?
Offer a terse response. 0.62. What is the ratio of the Value added (current US$) of Denmark in 1999 to that in 2004?
Your answer should be very brief. 0.73. What is the ratio of the Value added (current US$) in Eritrea in 1999 to that in 2004?
Offer a terse response. 0.66. What is the ratio of the Value added (current US$) of High income: nonOECD in 1999 to that in 2005?
Offer a terse response. 0.5. What is the ratio of the Value added (current US$) of Cyprus in 1999 to that in 2005?
Keep it short and to the point. 0.59. What is the ratio of the Value added (current US$) in Denmark in 1999 to that in 2005?
Offer a very short reply. 0.68. What is the ratio of the Value added (current US$) of Eritrea in 1999 to that in 2005?
Your answer should be very brief. 0.64. What is the ratio of the Value added (current US$) of High income: nonOECD in 1999 to that in 2006?
Provide a succinct answer. 0.42. What is the ratio of the Value added (current US$) of Cyprus in 1999 to that in 2006?
Keep it short and to the point. 0.54. What is the ratio of the Value added (current US$) in Denmark in 1999 to that in 2006?
Offer a very short reply. 0.62. What is the ratio of the Value added (current US$) of Eritrea in 1999 to that in 2006?
Make the answer very short. 0.65. What is the ratio of the Value added (current US$) of High income: nonOECD in 2000 to that in 2001?
Your answer should be compact. 1.03. What is the ratio of the Value added (current US$) in Cyprus in 2000 to that in 2001?
Provide a short and direct response. 0.98. What is the ratio of the Value added (current US$) in Denmark in 2000 to that in 2001?
Offer a very short reply. 1.03. What is the ratio of the Value added (current US$) in Eritrea in 2000 to that in 2001?
Provide a succinct answer. 0.97. What is the ratio of the Value added (current US$) in High income: nonOECD in 2000 to that in 2002?
Provide a succinct answer. 1.08. What is the ratio of the Value added (current US$) of Cyprus in 2000 to that in 2002?
Keep it short and to the point. 0.86. What is the ratio of the Value added (current US$) in Denmark in 2000 to that in 2002?
Your answer should be compact. 0.96. What is the ratio of the Value added (current US$) in Eritrea in 2000 to that in 2002?
Provide a short and direct response. 0.97. What is the ratio of the Value added (current US$) in High income: nonOECD in 2000 to that in 2003?
Make the answer very short. 0.95. What is the ratio of the Value added (current US$) in Cyprus in 2000 to that in 2003?
Your answer should be very brief. 0.67. What is the ratio of the Value added (current US$) of Denmark in 2000 to that in 2003?
Ensure brevity in your answer.  0.8. What is the ratio of the Value added (current US$) in Eritrea in 2000 to that in 2003?
Give a very brief answer. 0.79. What is the ratio of the Value added (current US$) of High income: nonOECD in 2000 to that in 2004?
Your response must be concise. 0.75. What is the ratio of the Value added (current US$) in Cyprus in 2000 to that in 2004?
Keep it short and to the point. 0.56. What is the ratio of the Value added (current US$) in Denmark in 2000 to that in 2004?
Offer a terse response. 0.7. What is the ratio of the Value added (current US$) of Eritrea in 2000 to that in 2004?
Offer a very short reply. 0.62. What is the ratio of the Value added (current US$) of High income: nonOECD in 2000 to that in 2005?
Your answer should be compact. 0.6. What is the ratio of the Value added (current US$) in Cyprus in 2000 to that in 2005?
Your answer should be very brief. 0.53. What is the ratio of the Value added (current US$) in Denmark in 2000 to that in 2005?
Provide a short and direct response. 0.66. What is the ratio of the Value added (current US$) in Eritrea in 2000 to that in 2005?
Keep it short and to the point. 0.6. What is the ratio of the Value added (current US$) in High income: nonOECD in 2000 to that in 2006?
Provide a short and direct response. 0.51. What is the ratio of the Value added (current US$) in Cyprus in 2000 to that in 2006?
Provide a succinct answer. 0.49. What is the ratio of the Value added (current US$) in Denmark in 2000 to that in 2006?
Your response must be concise. 0.6. What is the ratio of the Value added (current US$) in Eritrea in 2000 to that in 2006?
Ensure brevity in your answer.  0.62. What is the ratio of the Value added (current US$) in High income: nonOECD in 2001 to that in 2002?
Make the answer very short. 1.05. What is the ratio of the Value added (current US$) of Cyprus in 2001 to that in 2002?
Your answer should be compact. 0.88. What is the ratio of the Value added (current US$) in Denmark in 2001 to that in 2002?
Give a very brief answer. 0.93. What is the ratio of the Value added (current US$) in High income: nonOECD in 2001 to that in 2003?
Your response must be concise. 0.92. What is the ratio of the Value added (current US$) of Cyprus in 2001 to that in 2003?
Provide a short and direct response. 0.69. What is the ratio of the Value added (current US$) in Denmark in 2001 to that in 2003?
Provide a succinct answer. 0.78. What is the ratio of the Value added (current US$) of Eritrea in 2001 to that in 2003?
Provide a succinct answer. 0.81. What is the ratio of the Value added (current US$) in High income: nonOECD in 2001 to that in 2004?
Your answer should be very brief. 0.72. What is the ratio of the Value added (current US$) in Cyprus in 2001 to that in 2004?
Ensure brevity in your answer.  0.58. What is the ratio of the Value added (current US$) in Denmark in 2001 to that in 2004?
Give a very brief answer. 0.68. What is the ratio of the Value added (current US$) of Eritrea in 2001 to that in 2004?
Your answer should be very brief. 0.64. What is the ratio of the Value added (current US$) in High income: nonOECD in 2001 to that in 2005?
Offer a very short reply. 0.58. What is the ratio of the Value added (current US$) in Cyprus in 2001 to that in 2005?
Your answer should be compact. 0.55. What is the ratio of the Value added (current US$) of Denmark in 2001 to that in 2005?
Keep it short and to the point. 0.64. What is the ratio of the Value added (current US$) in Eritrea in 2001 to that in 2005?
Ensure brevity in your answer.  0.62. What is the ratio of the Value added (current US$) in High income: nonOECD in 2001 to that in 2006?
Offer a terse response. 0.49. What is the ratio of the Value added (current US$) in Cyprus in 2001 to that in 2006?
Offer a terse response. 0.51. What is the ratio of the Value added (current US$) in Denmark in 2001 to that in 2006?
Offer a terse response. 0.58. What is the ratio of the Value added (current US$) in Eritrea in 2001 to that in 2006?
Provide a succinct answer. 0.63. What is the ratio of the Value added (current US$) in High income: nonOECD in 2002 to that in 2003?
Your response must be concise. 0.88. What is the ratio of the Value added (current US$) of Cyprus in 2002 to that in 2003?
Offer a very short reply. 0.78. What is the ratio of the Value added (current US$) in Denmark in 2002 to that in 2003?
Give a very brief answer. 0.84. What is the ratio of the Value added (current US$) of Eritrea in 2002 to that in 2003?
Offer a terse response. 0.82. What is the ratio of the Value added (current US$) in High income: nonOECD in 2002 to that in 2004?
Ensure brevity in your answer.  0.69. What is the ratio of the Value added (current US$) of Cyprus in 2002 to that in 2004?
Make the answer very short. 0.65. What is the ratio of the Value added (current US$) of Denmark in 2002 to that in 2004?
Provide a short and direct response. 0.73. What is the ratio of the Value added (current US$) in Eritrea in 2002 to that in 2004?
Give a very brief answer. 0.64. What is the ratio of the Value added (current US$) in High income: nonOECD in 2002 to that in 2005?
Make the answer very short. 0.55. What is the ratio of the Value added (current US$) in Cyprus in 2002 to that in 2005?
Keep it short and to the point. 0.62. What is the ratio of the Value added (current US$) in Denmark in 2002 to that in 2005?
Provide a succinct answer. 0.69. What is the ratio of the Value added (current US$) of Eritrea in 2002 to that in 2005?
Provide a short and direct response. 0.62. What is the ratio of the Value added (current US$) of High income: nonOECD in 2002 to that in 2006?
Ensure brevity in your answer.  0.47. What is the ratio of the Value added (current US$) in Denmark in 2002 to that in 2006?
Ensure brevity in your answer.  0.62. What is the ratio of the Value added (current US$) in Eritrea in 2002 to that in 2006?
Keep it short and to the point. 0.64. What is the ratio of the Value added (current US$) of High income: nonOECD in 2003 to that in 2004?
Give a very brief answer. 0.79. What is the ratio of the Value added (current US$) in Cyprus in 2003 to that in 2004?
Make the answer very short. 0.84. What is the ratio of the Value added (current US$) in Denmark in 2003 to that in 2004?
Offer a very short reply. 0.87. What is the ratio of the Value added (current US$) of Eritrea in 2003 to that in 2004?
Give a very brief answer. 0.79. What is the ratio of the Value added (current US$) in High income: nonOECD in 2003 to that in 2005?
Ensure brevity in your answer.  0.63. What is the ratio of the Value added (current US$) in Cyprus in 2003 to that in 2005?
Offer a very short reply. 0.79. What is the ratio of the Value added (current US$) in Denmark in 2003 to that in 2005?
Ensure brevity in your answer.  0.82. What is the ratio of the Value added (current US$) of Eritrea in 2003 to that in 2005?
Offer a very short reply. 0.76. What is the ratio of the Value added (current US$) in High income: nonOECD in 2003 to that in 2006?
Offer a very short reply. 0.53. What is the ratio of the Value added (current US$) in Cyprus in 2003 to that in 2006?
Provide a succinct answer. 0.73. What is the ratio of the Value added (current US$) of Denmark in 2003 to that in 2006?
Give a very brief answer. 0.74. What is the ratio of the Value added (current US$) of Eritrea in 2003 to that in 2006?
Your answer should be compact. 0.78. What is the ratio of the Value added (current US$) in High income: nonOECD in 2004 to that in 2005?
Keep it short and to the point. 0.8. What is the ratio of the Value added (current US$) of Cyprus in 2004 to that in 2005?
Keep it short and to the point. 0.95. What is the ratio of the Value added (current US$) in Denmark in 2004 to that in 2005?
Ensure brevity in your answer.  0.94. What is the ratio of the Value added (current US$) in Eritrea in 2004 to that in 2005?
Make the answer very short. 0.97. What is the ratio of the Value added (current US$) in High income: nonOECD in 2004 to that in 2006?
Make the answer very short. 0.68. What is the ratio of the Value added (current US$) of Cyprus in 2004 to that in 2006?
Ensure brevity in your answer.  0.88. What is the ratio of the Value added (current US$) of Denmark in 2004 to that in 2006?
Provide a short and direct response. 0.85. What is the ratio of the Value added (current US$) of Eritrea in 2004 to that in 2006?
Ensure brevity in your answer.  0.99. What is the ratio of the Value added (current US$) of High income: nonOECD in 2005 to that in 2006?
Offer a terse response. 0.85. What is the ratio of the Value added (current US$) of Cyprus in 2005 to that in 2006?
Keep it short and to the point. 0.92. What is the ratio of the Value added (current US$) in Denmark in 2005 to that in 2006?
Keep it short and to the point. 0.91. What is the ratio of the Value added (current US$) of Eritrea in 2005 to that in 2006?
Your response must be concise. 1.02. What is the difference between the highest and the second highest Value added (current US$) of High income: nonOECD?
Ensure brevity in your answer.  2.05e+11. What is the difference between the highest and the second highest Value added (current US$) of Cyprus?
Your answer should be compact. 2.82e+08. What is the difference between the highest and the second highest Value added (current US$) of Denmark?
Ensure brevity in your answer.  6.02e+09. What is the difference between the highest and the second highest Value added (current US$) in Eritrea?
Offer a terse response. 4.90e+06. What is the difference between the highest and the lowest Value added (current US$) of High income: nonOECD?
Provide a succinct answer. 7.72e+11. What is the difference between the highest and the lowest Value added (current US$) in Cyprus?
Your response must be concise. 1.83e+09. What is the difference between the highest and the lowest Value added (current US$) of Denmark?
Your answer should be compact. 2.72e+1. What is the difference between the highest and the lowest Value added (current US$) in Eritrea?
Offer a very short reply. 8.94e+07. 